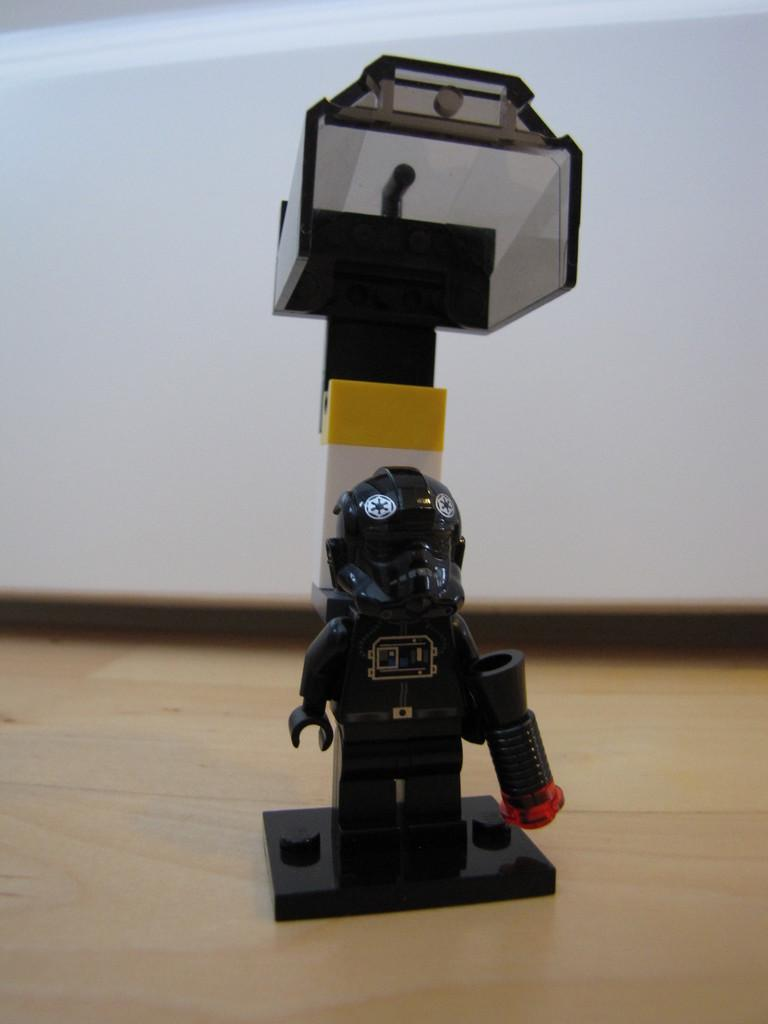What type of object can be seen in the image? There is a toy in the image. What is located at the bottom of the image? There is a table at the bottom of the image. Can you describe the object at the back of the image? There is an object at the back of the image, but its details are not clear from the provided facts. facts. What songs are being sung by the toy in the image? There is no indication in the image that the toy is singing songs, so it cannot be determined from the picture. 